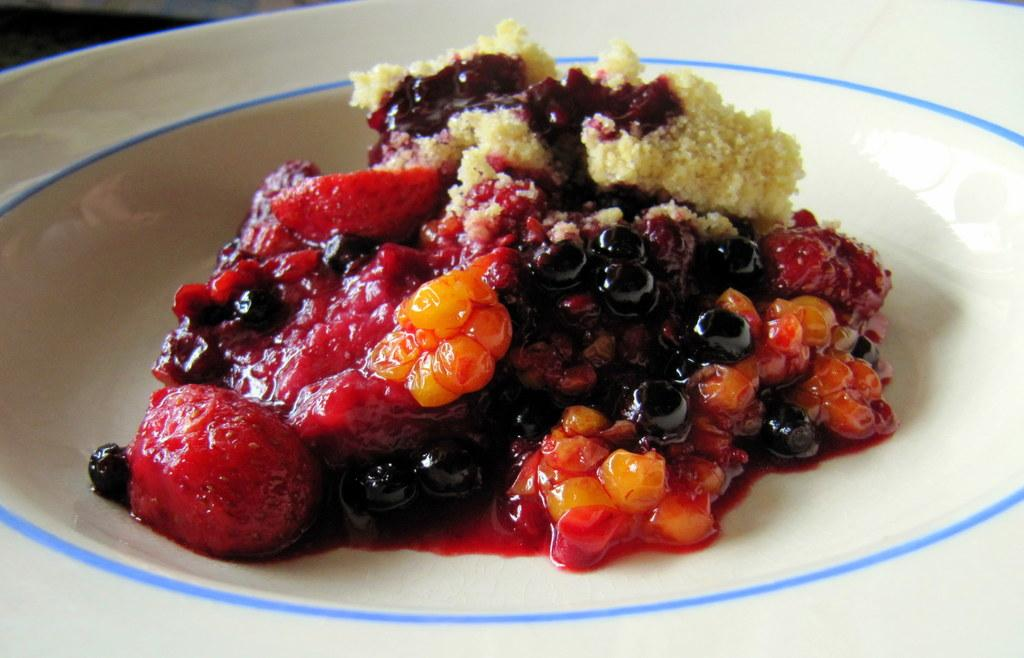What is present on the plate in the image? There is food on the plate in the image. What can be seen on top of the food? There is cream on the food. What else is added to the food on the plate? There is sauce on the food. What type of fairies can be seen causing a commotion in the image? There are no fairies present in the image, and therefore no commotion caused by them can be observed. 